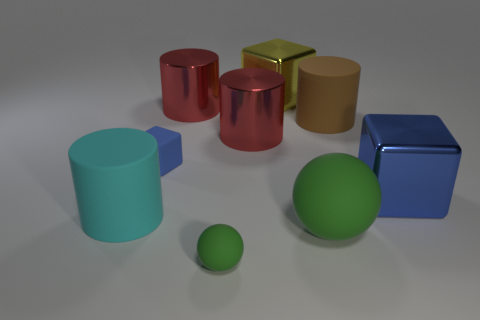How does the smoothness of the surfaces of the objects compare? In this image, we can observe that the surfaces of the objects vary. The red and blue metallic objects have reflective surfaces suggesting a high degree of smoothness, while the matte cube has a duller surface, showing it is less smooth. The differing textures are quite noticeable and affect how light interacts with each object. 